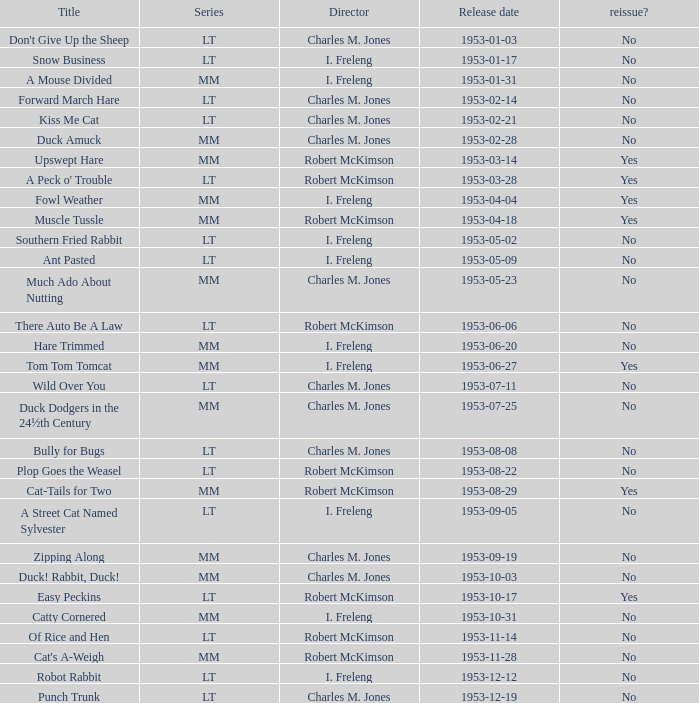What's the release date of Upswept Hare? 1953-03-14. 